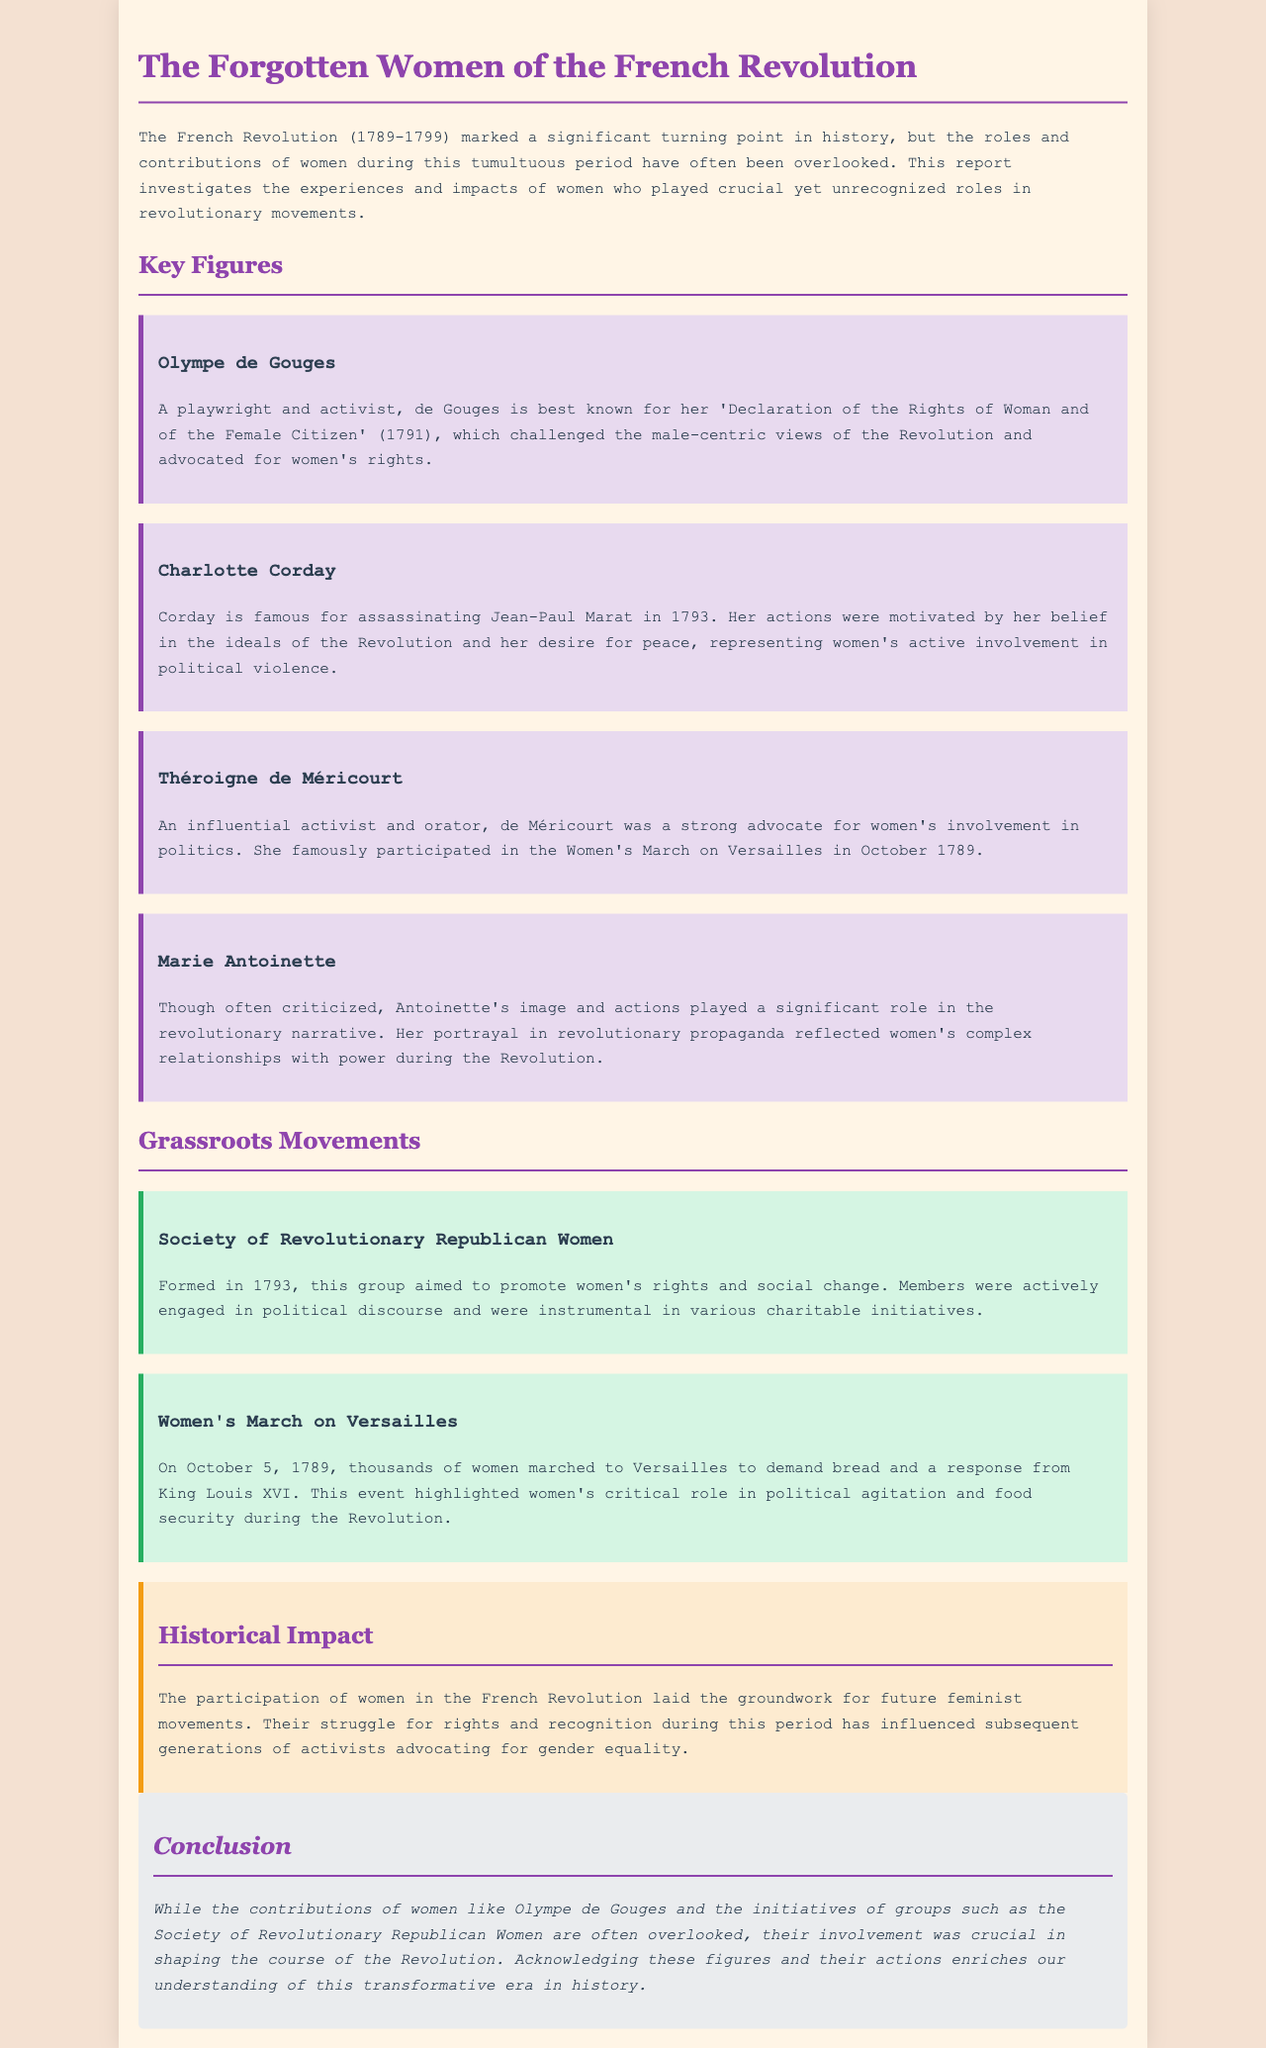What is the main focus of the report? The report focuses on the roles and experiences of women during the French Revolution, which have often been overlooked in traditional narratives.
Answer: women's roles Who wrote the 'Declaration of the Rights of Woman and of the Female Citizen'? Olympe de Gouges is known for writing this declaration, which challenged male-centric views.
Answer: Olympe de Gouges What year was the Society of Revolutionary Republican Women formed? The document states that this group was formed in 1793 to promote women's rights.
Answer: 1793 Which event is highlighted as critical for women's political agitation? The Women's March on Versailles is noted for demanding bread and a response from King Louis XVI.
Answer: Women's March on Versailles What was the primary goal of the Society of Revolutionary Republican Women? The society aimed to promote women's rights and social change within the revolutionary context.
Answer: women's rights How did Marie Antoinette's portrayal influence the revolutionary narrative? Her image and actions highlighted women's complex relationships with power during the Revolution.
Answer: complex relationships Which figure assassinated Jean-Paul Marat? Charlotte Corday is recognized for her assassination of Marat in 1793.
Answer: Charlotte Corday What impact did women's participation in the Revolution have on future movements? Women's involvement in the Revolution laid the groundwork for future feminist movements advocating for gender equality.
Answer: future feminist movements What type of document is this report classified as? This document is classified as an investigative report focusing on historical contributions of women.
Answer: investigative report 